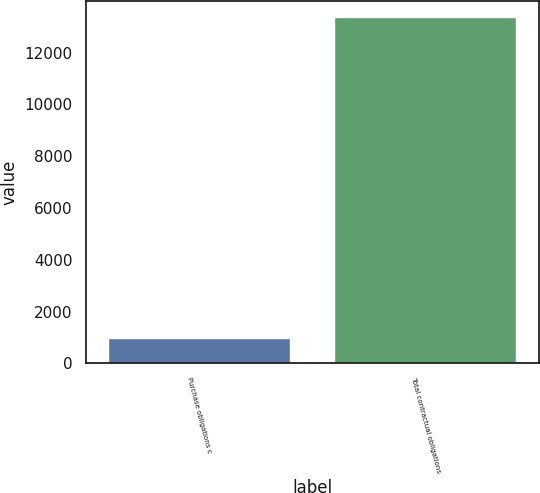Convert chart to OTSL. <chart><loc_0><loc_0><loc_500><loc_500><bar_chart><fcel>Purchase obligations c<fcel>Total contractual obligations<nl><fcel>954<fcel>13322<nl></chart> 